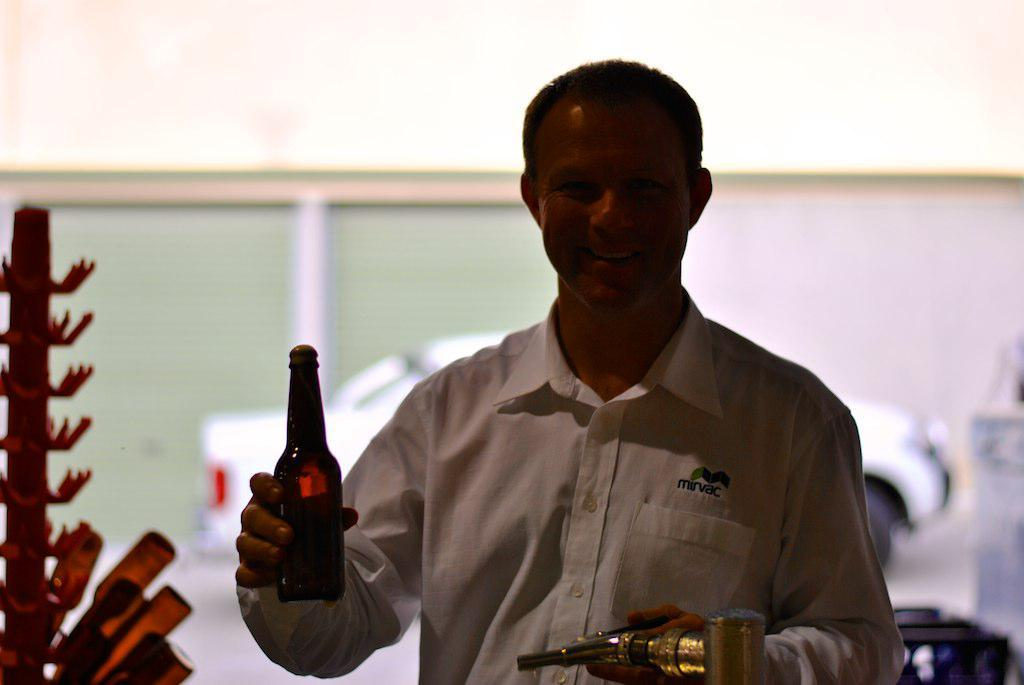What is the person in the image doing? The person is standing in the image. What is the person's facial expression? The person is smiling in the image. What object is the person holding? The person is holding a bottle in the image. How many balls can be seen in the image? There are no balls present in the image. What type of pump is being used by the person in the image? There is no pump present in the image. 